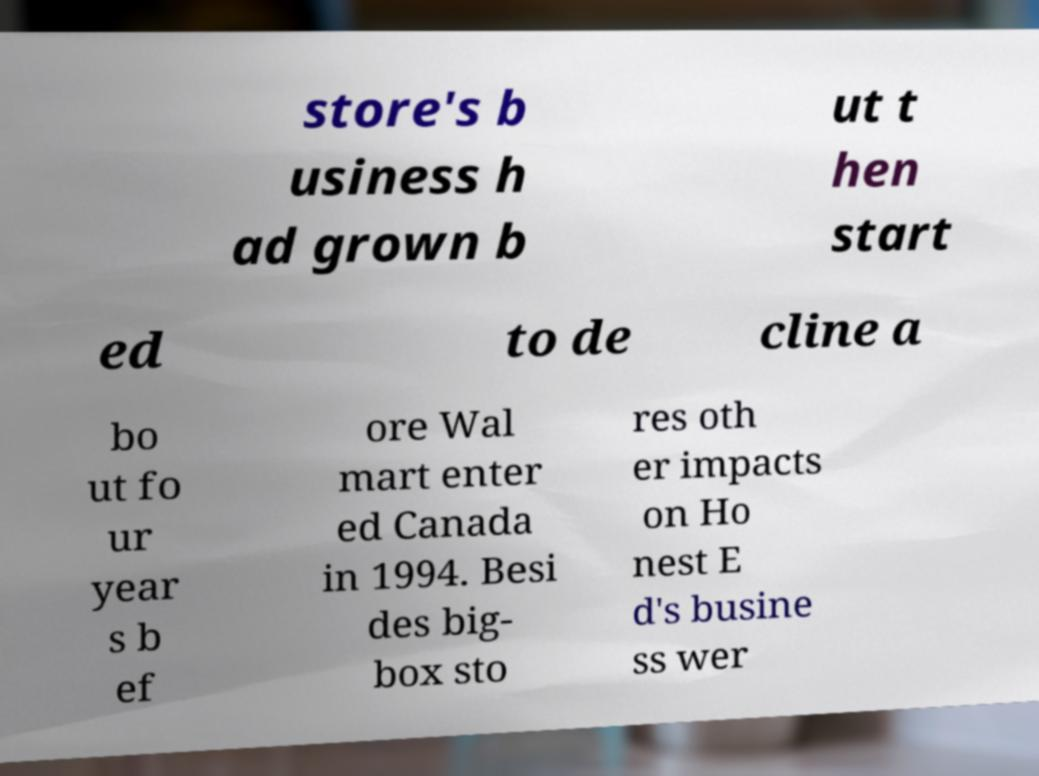I need the written content from this picture converted into text. Can you do that? store's b usiness h ad grown b ut t hen start ed to de cline a bo ut fo ur year s b ef ore Wal mart enter ed Canada in 1994. Besi des big- box sto res oth er impacts on Ho nest E d's busine ss wer 